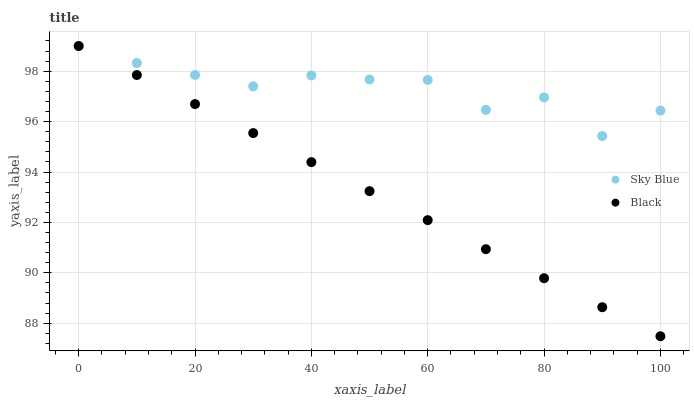Does Black have the minimum area under the curve?
Answer yes or no. Yes. Does Sky Blue have the maximum area under the curve?
Answer yes or no. Yes. Does Black have the maximum area under the curve?
Answer yes or no. No. Is Black the smoothest?
Answer yes or no. Yes. Is Sky Blue the roughest?
Answer yes or no. Yes. Is Black the roughest?
Answer yes or no. No. Does Black have the lowest value?
Answer yes or no. Yes. Does Black have the highest value?
Answer yes or no. Yes. Does Sky Blue intersect Black?
Answer yes or no. Yes. Is Sky Blue less than Black?
Answer yes or no. No. Is Sky Blue greater than Black?
Answer yes or no. No. 